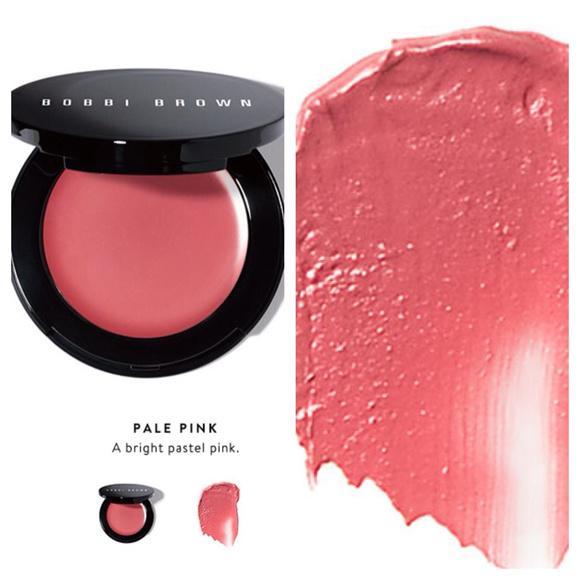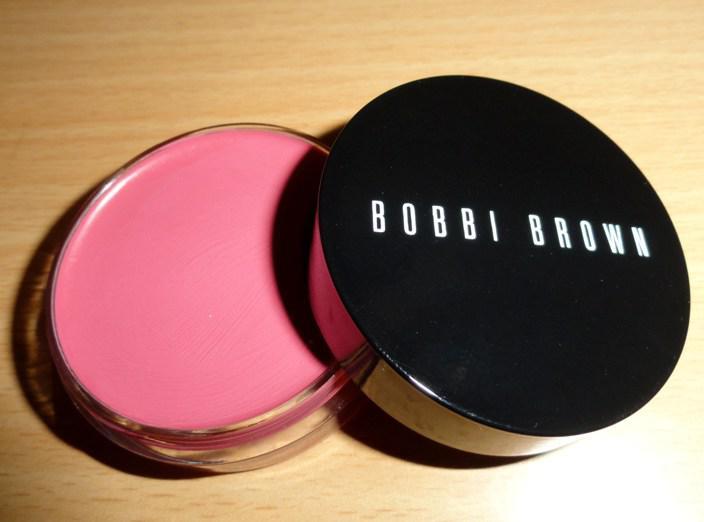The first image is the image on the left, the second image is the image on the right. Analyze the images presented: Is the assertion "In one of the images the makeup is sitting upon a wooden surface." valid? Answer yes or no. Yes. The first image is the image on the left, the second image is the image on the right. For the images displayed, is the sentence "One image shows one opened pot of pink rouge sitting on a wood-look surface." factually correct? Answer yes or no. Yes. 